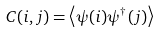<formula> <loc_0><loc_0><loc_500><loc_500>C ( i , j ) = \left \langle \psi ( i ) \psi ^ { \dagger } ( j ) \right \rangle</formula> 